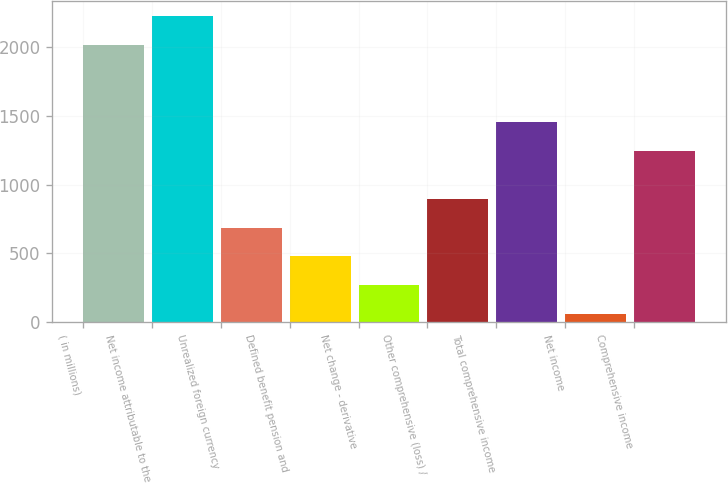Convert chart to OTSL. <chart><loc_0><loc_0><loc_500><loc_500><bar_chart><fcel>( in millions)<fcel>Net income attributable to the<fcel>Unrealized foreign currency<fcel>Defined benefit pension and<fcel>Net change - derivative<fcel>Other comprehensive (loss) /<fcel>Total comprehensive income<fcel>Net income<fcel>Comprehensive income<nl><fcel>2014<fcel>2224.2<fcel>687.6<fcel>477.4<fcel>267.2<fcel>897.8<fcel>1456.2<fcel>57<fcel>1246<nl></chart> 